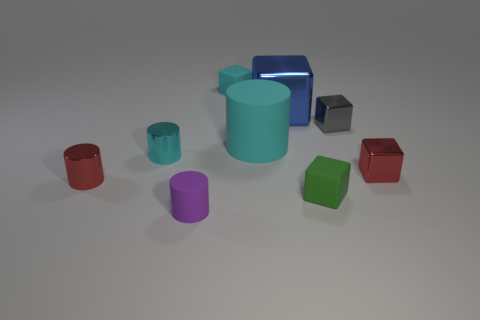Subtract all red cubes. How many cyan cylinders are left? 2 Subtract all tiny green blocks. How many blocks are left? 4 Add 1 large cyan matte things. How many objects exist? 10 Subtract 1 cylinders. How many cylinders are left? 3 Subtract all cyan cylinders. How many cylinders are left? 2 Subtract all cubes. How many objects are left? 4 Subtract all blue cylinders. Subtract all yellow blocks. How many cylinders are left? 4 Subtract all tiny rubber blocks. Subtract all big blue metallic objects. How many objects are left? 6 Add 4 blue metal objects. How many blue metal objects are left? 5 Add 8 blue rubber cubes. How many blue rubber cubes exist? 8 